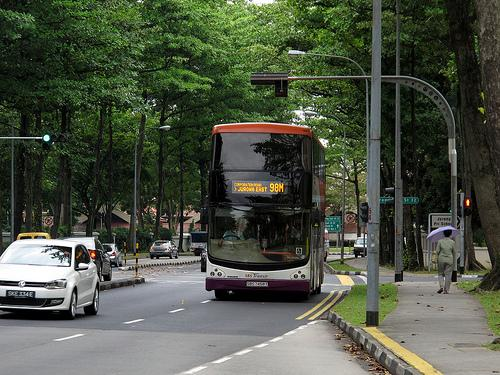Question: what is on the right?
Choices:
A. A bicycle.
B. A trolleycar.
C. A bus.
D. A train.
Answer with the letter. Answer: C Question: what type of bus is this?
Choices:
A. A double decker.
B. A countyline bus.
C. A city bus.
D. A commuter bus.
Answer with the letter. Answer: A Question: where was the photo taken?
Choices:
A. At a mall.
B. At a park.
C. On a road.
D. At a waterfall.
Answer with the letter. Answer: C Question: when was the photo taken?
Choices:
A. Midnight.
B. At dawn.
C. At daybreak.
D. During the day.
Answer with the letter. Answer: D Question: what is on the left?
Choices:
A. A motorcycle.
B. A Van.
C. Cars.
D. A moped.
Answer with the letter. Answer: C Question: how many buses are there?
Choices:
A. Two.
B. Three.
C. Four.
D. One.
Answer with the letter. Answer: D Question: what is on the side of the road?
Choices:
A. A stop sign.
B. A trash bin.
C. A parking cone.
D. Traffic lights.
Answer with the letter. Answer: D 